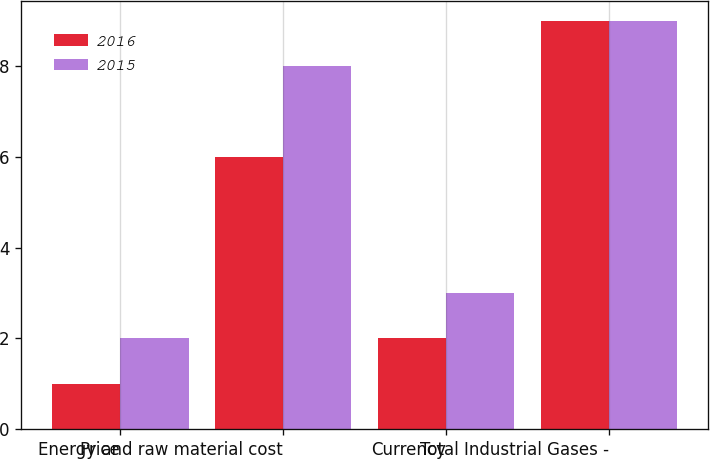Convert chart to OTSL. <chart><loc_0><loc_0><loc_500><loc_500><stacked_bar_chart><ecel><fcel>Price<fcel>Energy and raw material cost<fcel>Currency<fcel>Total Industrial Gases -<nl><fcel>2016<fcel>1<fcel>6<fcel>2<fcel>9<nl><fcel>2015<fcel>2<fcel>8<fcel>3<fcel>9<nl></chart> 